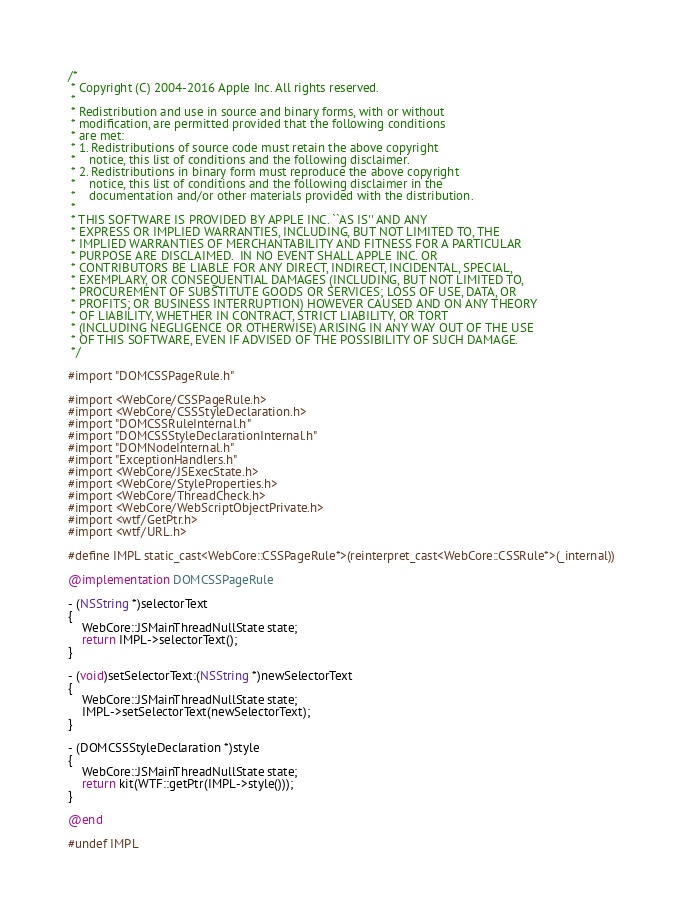<code> <loc_0><loc_0><loc_500><loc_500><_ObjectiveC_>/*
 * Copyright (C) 2004-2016 Apple Inc. All rights reserved.
 *
 * Redistribution and use in source and binary forms, with or without
 * modification, are permitted provided that the following conditions
 * are met:
 * 1. Redistributions of source code must retain the above copyright
 *    notice, this list of conditions and the following disclaimer.
 * 2. Redistributions in binary form must reproduce the above copyright
 *    notice, this list of conditions and the following disclaimer in the
 *    documentation and/or other materials provided with the distribution.
 *
 * THIS SOFTWARE IS PROVIDED BY APPLE INC. ``AS IS'' AND ANY
 * EXPRESS OR IMPLIED WARRANTIES, INCLUDING, BUT NOT LIMITED TO, THE
 * IMPLIED WARRANTIES OF MERCHANTABILITY AND FITNESS FOR A PARTICULAR
 * PURPOSE ARE DISCLAIMED.  IN NO EVENT SHALL APPLE INC. OR
 * CONTRIBUTORS BE LIABLE FOR ANY DIRECT, INDIRECT, INCIDENTAL, SPECIAL,
 * EXEMPLARY, OR CONSEQUENTIAL DAMAGES (INCLUDING, BUT NOT LIMITED TO,
 * PROCUREMENT OF SUBSTITUTE GOODS OR SERVICES; LOSS OF USE, DATA, OR
 * PROFITS; OR BUSINESS INTERRUPTION) HOWEVER CAUSED AND ON ANY THEORY
 * OF LIABILITY, WHETHER IN CONTRACT, STRICT LIABILITY, OR TORT
 * (INCLUDING NEGLIGENCE OR OTHERWISE) ARISING IN ANY WAY OUT OF THE USE
 * OF THIS SOFTWARE, EVEN IF ADVISED OF THE POSSIBILITY OF SUCH DAMAGE.
 */

#import "DOMCSSPageRule.h"

#import <WebCore/CSSPageRule.h>
#import <WebCore/CSSStyleDeclaration.h>
#import "DOMCSSRuleInternal.h"
#import "DOMCSSStyleDeclarationInternal.h"
#import "DOMNodeInternal.h"
#import "ExceptionHandlers.h"
#import <WebCore/JSExecState.h>
#import <WebCore/StyleProperties.h>
#import <WebCore/ThreadCheck.h>
#import <WebCore/WebScriptObjectPrivate.h>
#import <wtf/GetPtr.h>
#import <wtf/URL.h>

#define IMPL static_cast<WebCore::CSSPageRule*>(reinterpret_cast<WebCore::CSSRule*>(_internal))

@implementation DOMCSSPageRule

- (NSString *)selectorText
{
    WebCore::JSMainThreadNullState state;
    return IMPL->selectorText();
}

- (void)setSelectorText:(NSString *)newSelectorText
{
    WebCore::JSMainThreadNullState state;
    IMPL->setSelectorText(newSelectorText);
}

- (DOMCSSStyleDeclaration *)style
{
    WebCore::JSMainThreadNullState state;
    return kit(WTF::getPtr(IMPL->style()));
}

@end

#undef IMPL
</code> 